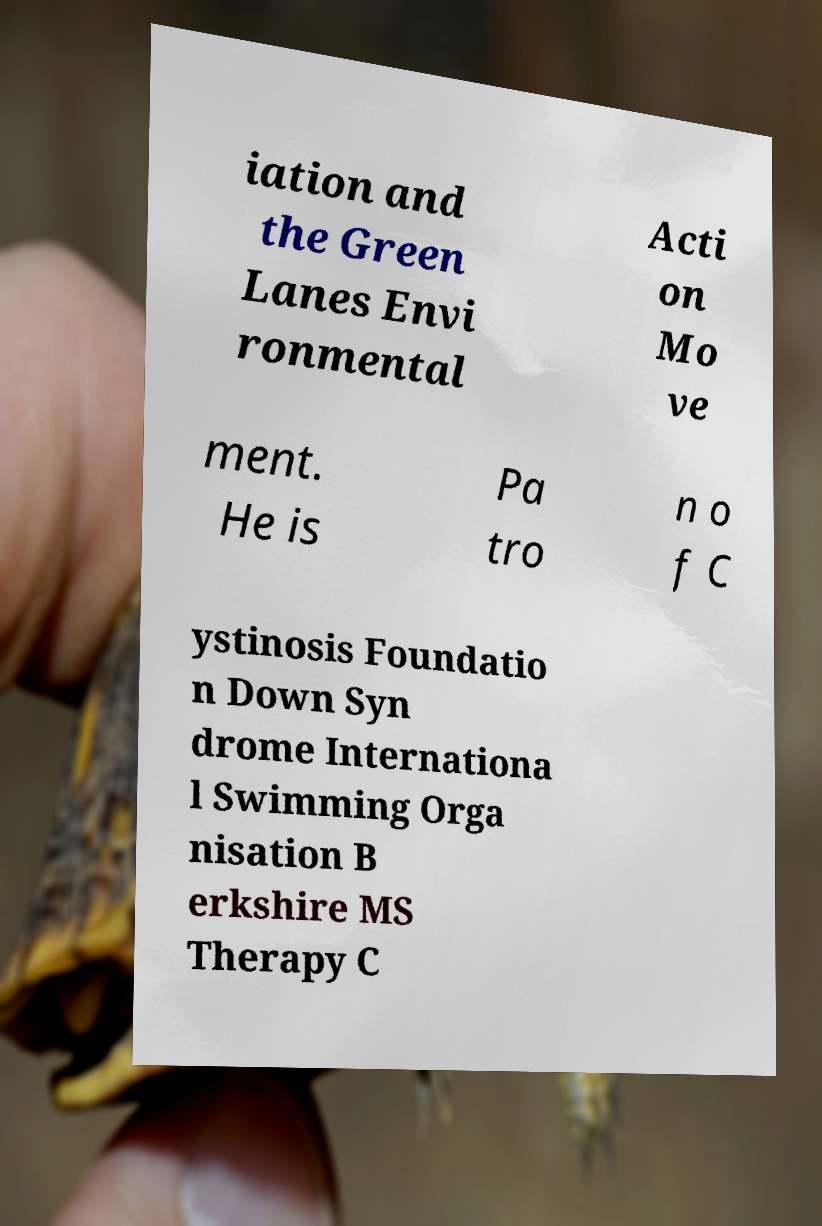Can you accurately transcribe the text from the provided image for me? iation and the Green Lanes Envi ronmental Acti on Mo ve ment. He is Pa tro n o f C ystinosis Foundatio n Down Syn drome Internationa l Swimming Orga nisation B erkshire MS Therapy C 